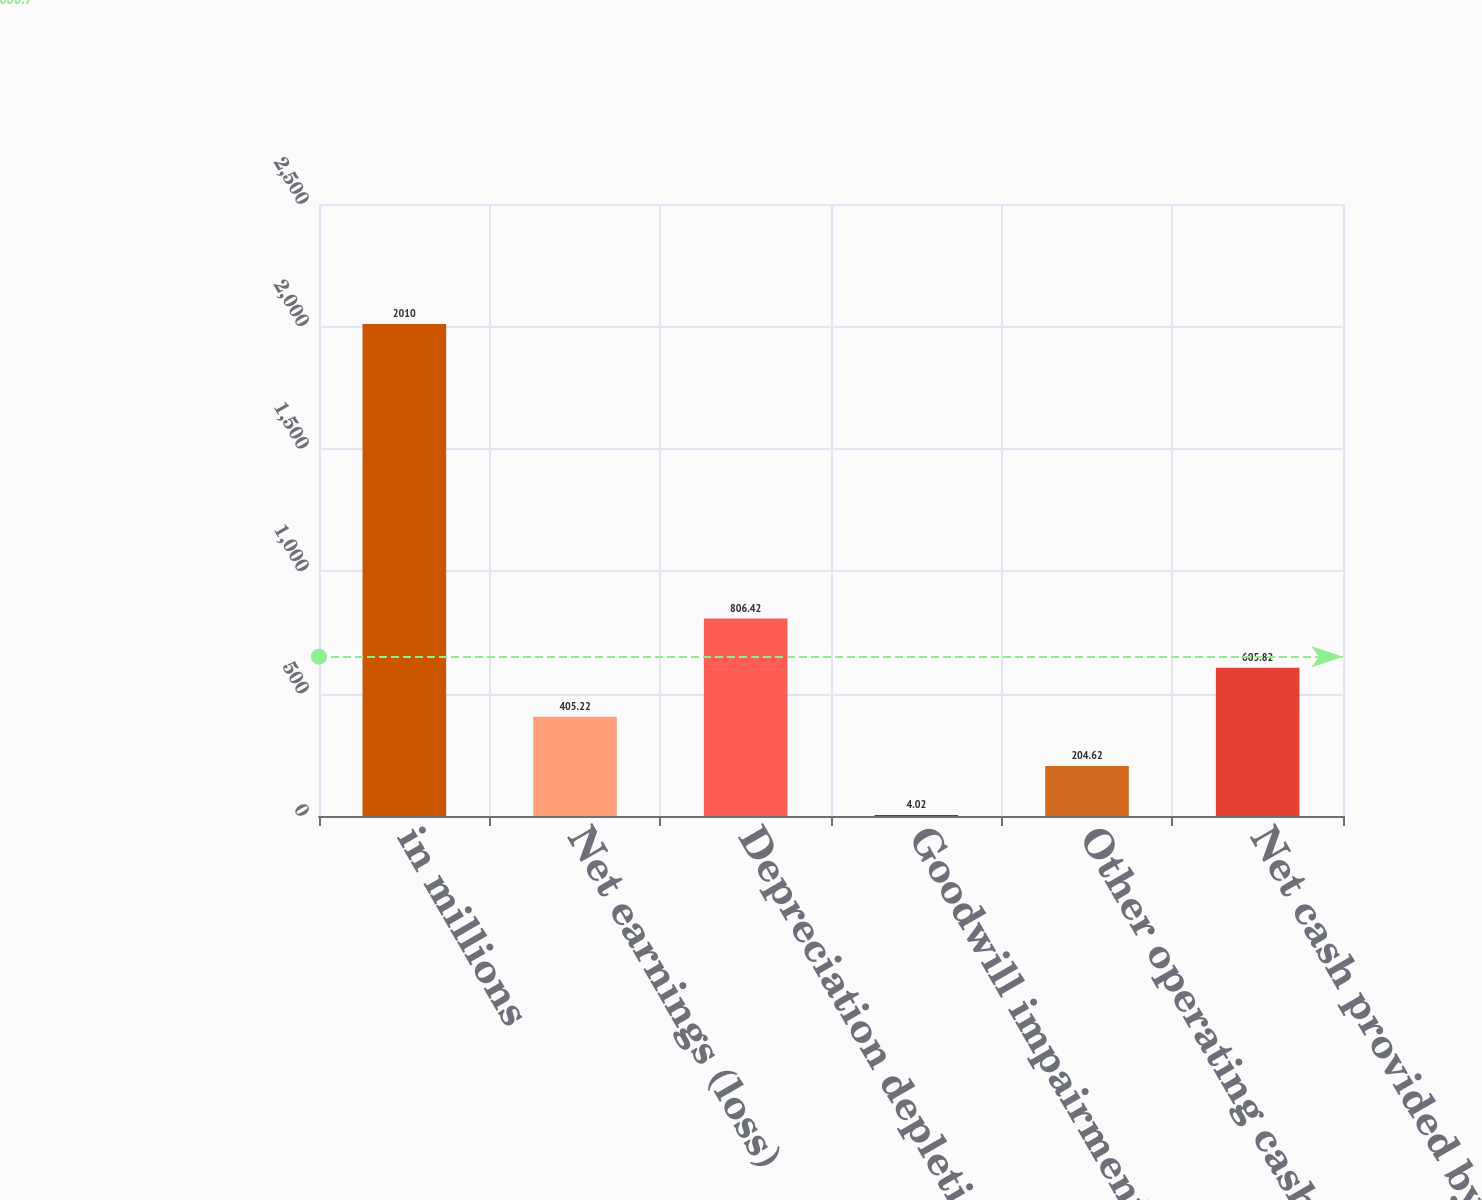<chart> <loc_0><loc_0><loc_500><loc_500><bar_chart><fcel>in millions<fcel>Net earnings (loss)<fcel>Depreciation depletion<fcel>Goodwill impairment<fcel>Other operating cash flows net<fcel>Net cash provided by operating<nl><fcel>2010<fcel>405.22<fcel>806.42<fcel>4.02<fcel>204.62<fcel>605.82<nl></chart> 